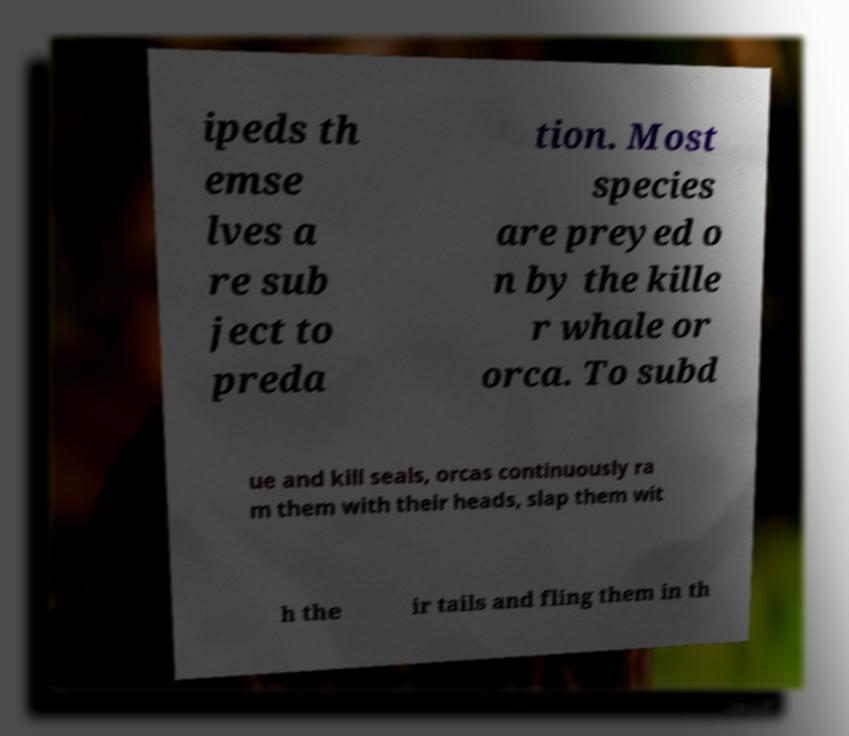Please read and relay the text visible in this image. What does it say? ipeds th emse lves a re sub ject to preda tion. Most species are preyed o n by the kille r whale or orca. To subd ue and kill seals, orcas continuously ra m them with their heads, slap them wit h the ir tails and fling them in th 